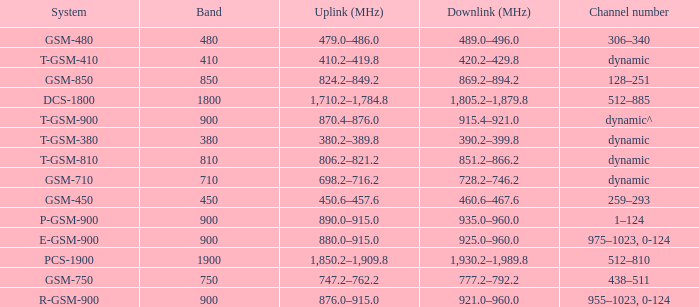What band is the highest and has a System of gsm-450? 450.0. 